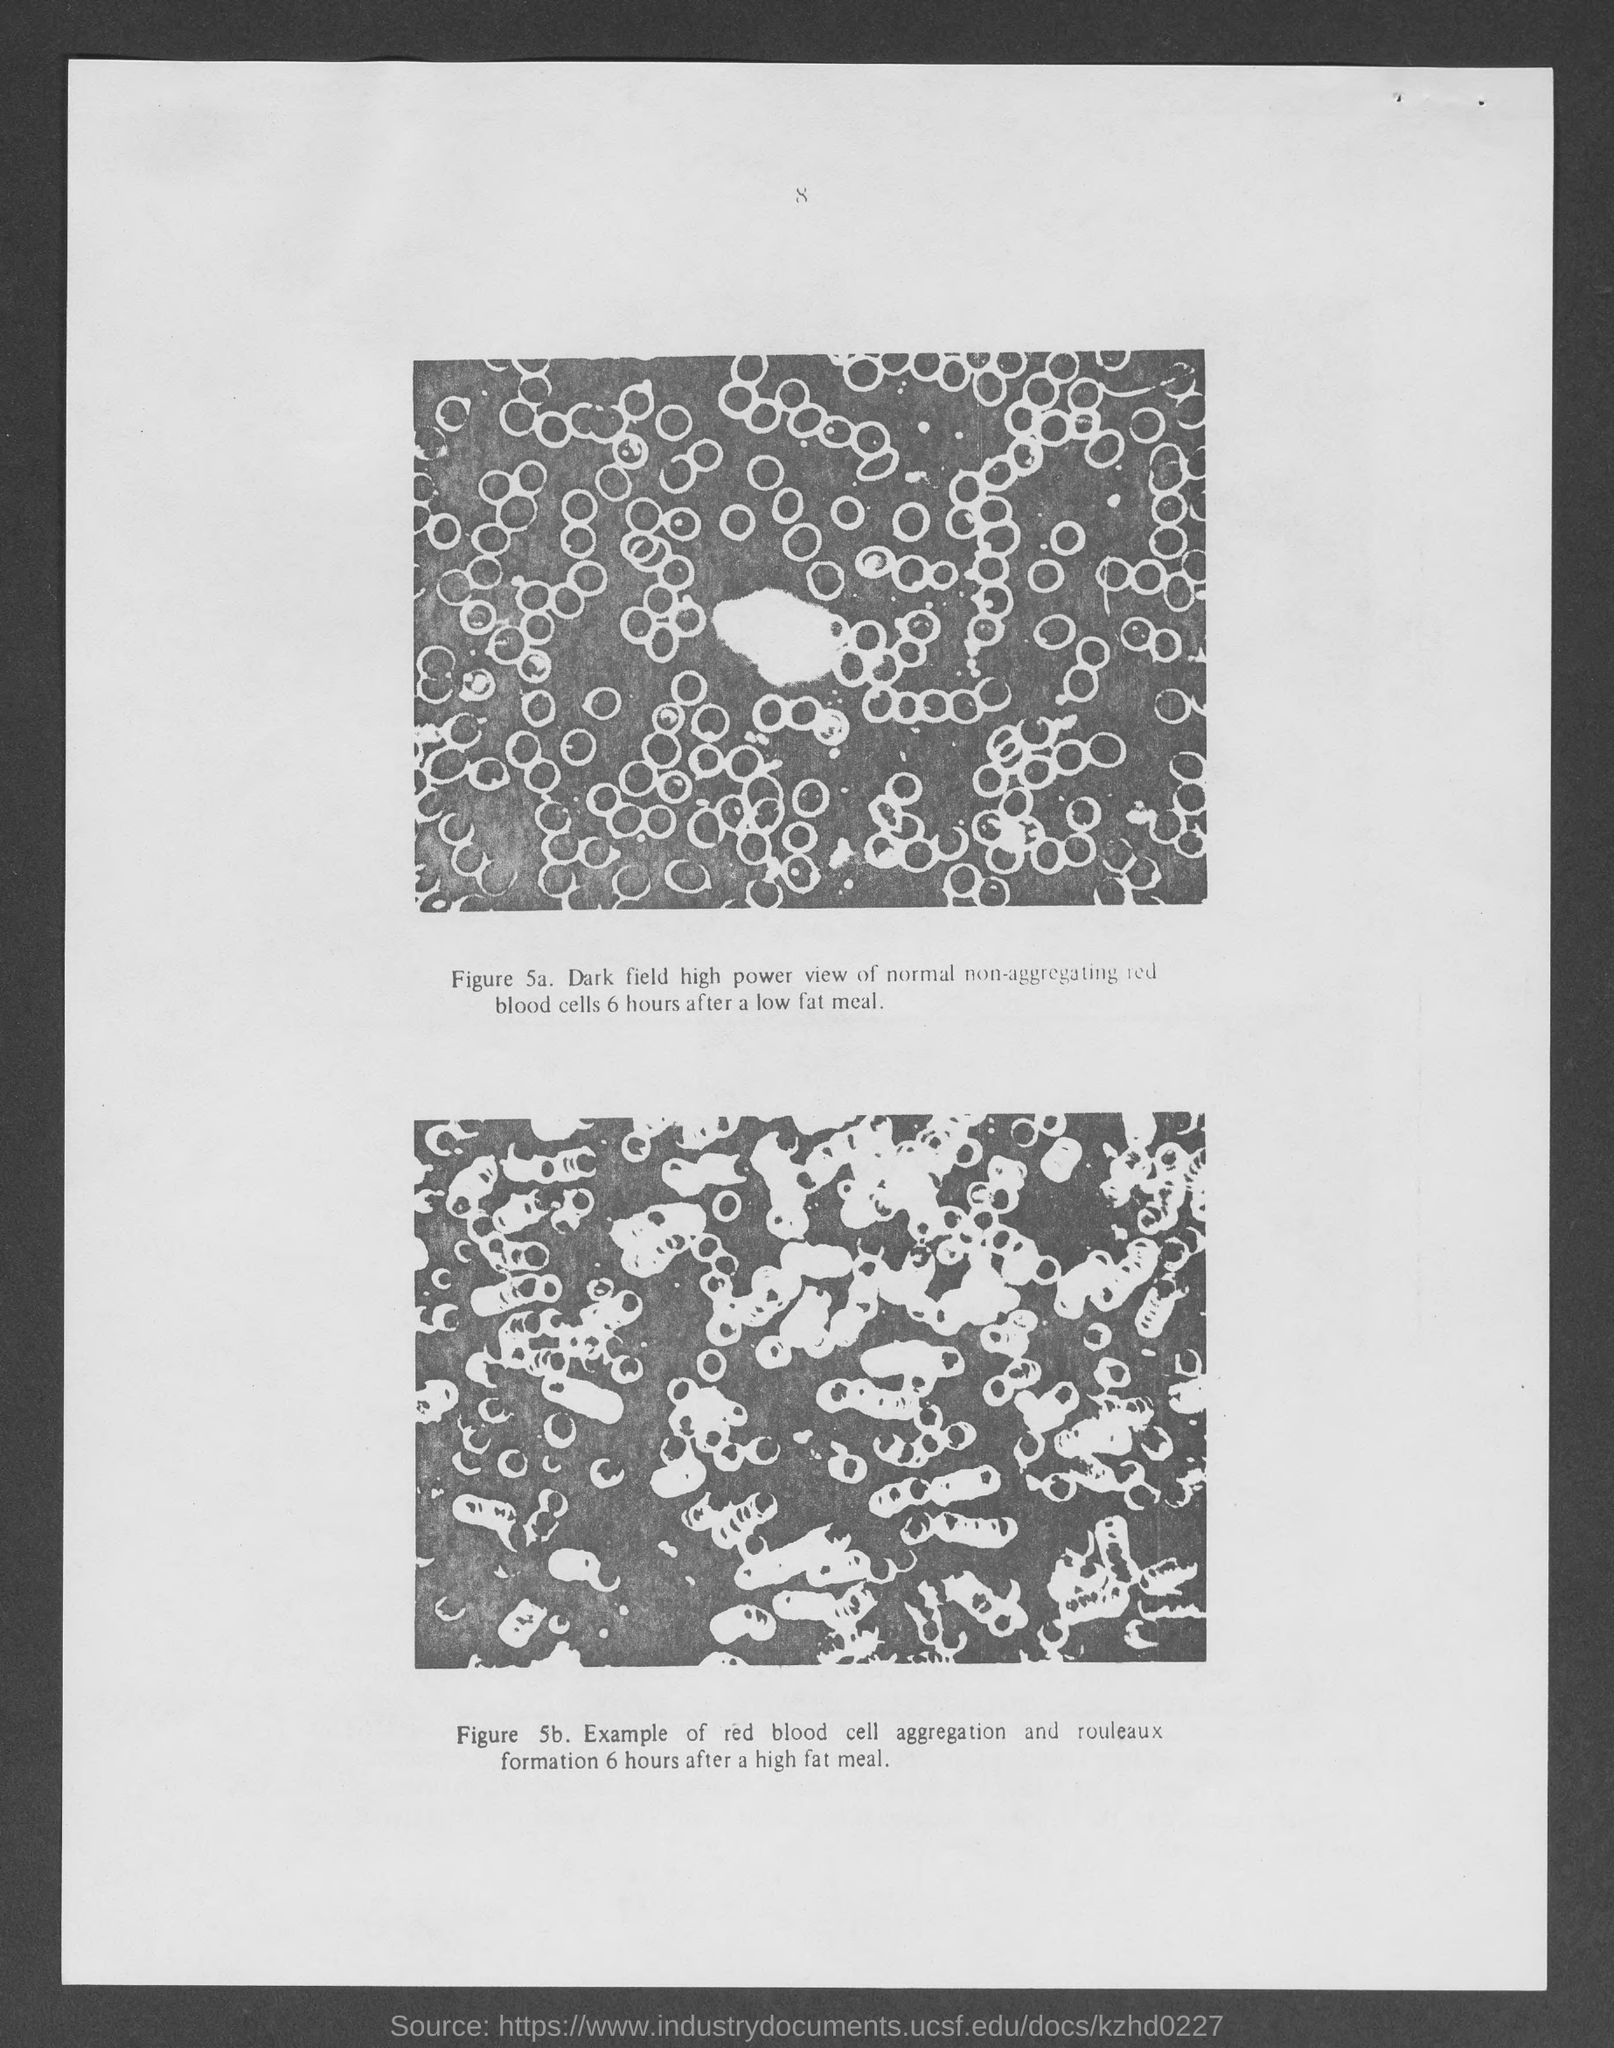What is the number at top of the page ?
Provide a short and direct response. 8. 